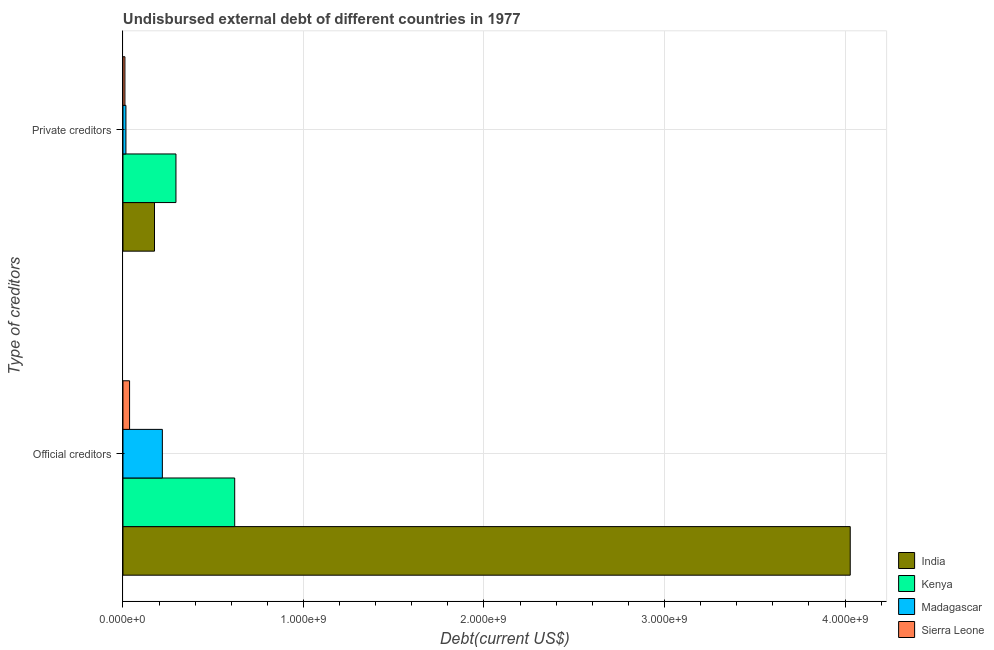Are the number of bars on each tick of the Y-axis equal?
Your response must be concise. Yes. What is the label of the 1st group of bars from the top?
Your answer should be compact. Private creditors. What is the undisbursed external debt of private creditors in Kenya?
Offer a terse response. 2.93e+08. Across all countries, what is the maximum undisbursed external debt of official creditors?
Make the answer very short. 4.03e+09. Across all countries, what is the minimum undisbursed external debt of official creditors?
Your response must be concise. 3.66e+07. In which country was the undisbursed external debt of private creditors minimum?
Provide a short and direct response. Sierra Leone. What is the total undisbursed external debt of official creditors in the graph?
Provide a short and direct response. 4.90e+09. What is the difference between the undisbursed external debt of private creditors in Sierra Leone and that in Madagascar?
Your answer should be very brief. -5.58e+06. What is the difference between the undisbursed external debt of private creditors in Madagascar and the undisbursed external debt of official creditors in Sierra Leone?
Provide a short and direct response. -2.03e+07. What is the average undisbursed external debt of official creditors per country?
Your answer should be compact. 1.23e+09. What is the difference between the undisbursed external debt of private creditors and undisbursed external debt of official creditors in India?
Your answer should be very brief. -3.85e+09. What is the ratio of the undisbursed external debt of private creditors in Sierra Leone to that in Madagascar?
Give a very brief answer. 0.66. Is the undisbursed external debt of official creditors in Madagascar less than that in India?
Offer a very short reply. Yes. In how many countries, is the undisbursed external debt of private creditors greater than the average undisbursed external debt of private creditors taken over all countries?
Give a very brief answer. 2. What does the 2nd bar from the top in Official creditors represents?
Ensure brevity in your answer.  Madagascar. What does the 3rd bar from the bottom in Official creditors represents?
Offer a terse response. Madagascar. How many bars are there?
Your response must be concise. 8. Are all the bars in the graph horizontal?
Your answer should be compact. Yes. How many countries are there in the graph?
Keep it short and to the point. 4. What is the difference between two consecutive major ticks on the X-axis?
Give a very brief answer. 1.00e+09. Are the values on the major ticks of X-axis written in scientific E-notation?
Your answer should be very brief. Yes. Does the graph contain any zero values?
Give a very brief answer. No. How many legend labels are there?
Give a very brief answer. 4. How are the legend labels stacked?
Your response must be concise. Vertical. What is the title of the graph?
Your answer should be very brief. Undisbursed external debt of different countries in 1977. What is the label or title of the X-axis?
Provide a succinct answer. Debt(current US$). What is the label or title of the Y-axis?
Make the answer very short. Type of creditors. What is the Debt(current US$) in India in Official creditors?
Provide a succinct answer. 4.03e+09. What is the Debt(current US$) in Kenya in Official creditors?
Provide a succinct answer. 6.19e+08. What is the Debt(current US$) in Madagascar in Official creditors?
Provide a succinct answer. 2.18e+08. What is the Debt(current US$) in Sierra Leone in Official creditors?
Your answer should be very brief. 3.66e+07. What is the Debt(current US$) in India in Private creditors?
Your response must be concise. 1.75e+08. What is the Debt(current US$) of Kenya in Private creditors?
Your answer should be compact. 2.93e+08. What is the Debt(current US$) in Madagascar in Private creditors?
Provide a succinct answer. 1.63e+07. What is the Debt(current US$) in Sierra Leone in Private creditors?
Provide a succinct answer. 1.07e+07. Across all Type of creditors, what is the maximum Debt(current US$) in India?
Offer a very short reply. 4.03e+09. Across all Type of creditors, what is the maximum Debt(current US$) in Kenya?
Keep it short and to the point. 6.19e+08. Across all Type of creditors, what is the maximum Debt(current US$) in Madagascar?
Provide a succinct answer. 2.18e+08. Across all Type of creditors, what is the maximum Debt(current US$) in Sierra Leone?
Your answer should be very brief. 3.66e+07. Across all Type of creditors, what is the minimum Debt(current US$) in India?
Offer a very short reply. 1.75e+08. Across all Type of creditors, what is the minimum Debt(current US$) of Kenya?
Ensure brevity in your answer.  2.93e+08. Across all Type of creditors, what is the minimum Debt(current US$) in Madagascar?
Offer a terse response. 1.63e+07. Across all Type of creditors, what is the minimum Debt(current US$) of Sierra Leone?
Offer a terse response. 1.07e+07. What is the total Debt(current US$) in India in the graph?
Your answer should be compact. 4.20e+09. What is the total Debt(current US$) in Kenya in the graph?
Your response must be concise. 9.12e+08. What is the total Debt(current US$) in Madagascar in the graph?
Provide a succinct answer. 2.34e+08. What is the total Debt(current US$) of Sierra Leone in the graph?
Make the answer very short. 4.73e+07. What is the difference between the Debt(current US$) in India in Official creditors and that in Private creditors?
Ensure brevity in your answer.  3.85e+09. What is the difference between the Debt(current US$) in Kenya in Official creditors and that in Private creditors?
Offer a very short reply. 3.25e+08. What is the difference between the Debt(current US$) in Madagascar in Official creditors and that in Private creditors?
Provide a succinct answer. 2.02e+08. What is the difference between the Debt(current US$) of Sierra Leone in Official creditors and that in Private creditors?
Your response must be concise. 2.58e+07. What is the difference between the Debt(current US$) in India in Official creditors and the Debt(current US$) in Kenya in Private creditors?
Keep it short and to the point. 3.74e+09. What is the difference between the Debt(current US$) in India in Official creditors and the Debt(current US$) in Madagascar in Private creditors?
Your answer should be very brief. 4.01e+09. What is the difference between the Debt(current US$) of India in Official creditors and the Debt(current US$) of Sierra Leone in Private creditors?
Your response must be concise. 4.02e+09. What is the difference between the Debt(current US$) in Kenya in Official creditors and the Debt(current US$) in Madagascar in Private creditors?
Make the answer very short. 6.03e+08. What is the difference between the Debt(current US$) in Kenya in Official creditors and the Debt(current US$) in Sierra Leone in Private creditors?
Give a very brief answer. 6.08e+08. What is the difference between the Debt(current US$) of Madagascar in Official creditors and the Debt(current US$) of Sierra Leone in Private creditors?
Provide a succinct answer. 2.07e+08. What is the average Debt(current US$) in India per Type of creditors?
Keep it short and to the point. 2.10e+09. What is the average Debt(current US$) in Kenya per Type of creditors?
Your answer should be very brief. 4.56e+08. What is the average Debt(current US$) in Madagascar per Type of creditors?
Your response must be concise. 1.17e+08. What is the average Debt(current US$) of Sierra Leone per Type of creditors?
Offer a very short reply. 2.36e+07. What is the difference between the Debt(current US$) of India and Debt(current US$) of Kenya in Official creditors?
Your response must be concise. 3.41e+09. What is the difference between the Debt(current US$) of India and Debt(current US$) of Madagascar in Official creditors?
Give a very brief answer. 3.81e+09. What is the difference between the Debt(current US$) of India and Debt(current US$) of Sierra Leone in Official creditors?
Offer a terse response. 3.99e+09. What is the difference between the Debt(current US$) of Kenya and Debt(current US$) of Madagascar in Official creditors?
Offer a terse response. 4.01e+08. What is the difference between the Debt(current US$) of Kenya and Debt(current US$) of Sierra Leone in Official creditors?
Your answer should be very brief. 5.82e+08. What is the difference between the Debt(current US$) of Madagascar and Debt(current US$) of Sierra Leone in Official creditors?
Your response must be concise. 1.82e+08. What is the difference between the Debt(current US$) in India and Debt(current US$) in Kenya in Private creditors?
Your response must be concise. -1.19e+08. What is the difference between the Debt(current US$) of India and Debt(current US$) of Madagascar in Private creditors?
Provide a short and direct response. 1.58e+08. What is the difference between the Debt(current US$) in India and Debt(current US$) in Sierra Leone in Private creditors?
Give a very brief answer. 1.64e+08. What is the difference between the Debt(current US$) of Kenya and Debt(current US$) of Madagascar in Private creditors?
Keep it short and to the point. 2.77e+08. What is the difference between the Debt(current US$) in Kenya and Debt(current US$) in Sierra Leone in Private creditors?
Give a very brief answer. 2.83e+08. What is the difference between the Debt(current US$) in Madagascar and Debt(current US$) in Sierra Leone in Private creditors?
Your answer should be very brief. 5.58e+06. What is the ratio of the Debt(current US$) in India in Official creditors to that in Private creditors?
Keep it short and to the point. 23.07. What is the ratio of the Debt(current US$) of Kenya in Official creditors to that in Private creditors?
Keep it short and to the point. 2.11. What is the ratio of the Debt(current US$) in Madagascar in Official creditors to that in Private creditors?
Make the answer very short. 13.38. What is the ratio of the Debt(current US$) of Sierra Leone in Official creditors to that in Private creditors?
Your answer should be compact. 3.41. What is the difference between the highest and the second highest Debt(current US$) of India?
Provide a short and direct response. 3.85e+09. What is the difference between the highest and the second highest Debt(current US$) of Kenya?
Provide a succinct answer. 3.25e+08. What is the difference between the highest and the second highest Debt(current US$) of Madagascar?
Provide a short and direct response. 2.02e+08. What is the difference between the highest and the second highest Debt(current US$) in Sierra Leone?
Your response must be concise. 2.58e+07. What is the difference between the highest and the lowest Debt(current US$) of India?
Ensure brevity in your answer.  3.85e+09. What is the difference between the highest and the lowest Debt(current US$) of Kenya?
Offer a very short reply. 3.25e+08. What is the difference between the highest and the lowest Debt(current US$) of Madagascar?
Ensure brevity in your answer.  2.02e+08. What is the difference between the highest and the lowest Debt(current US$) of Sierra Leone?
Provide a succinct answer. 2.58e+07. 